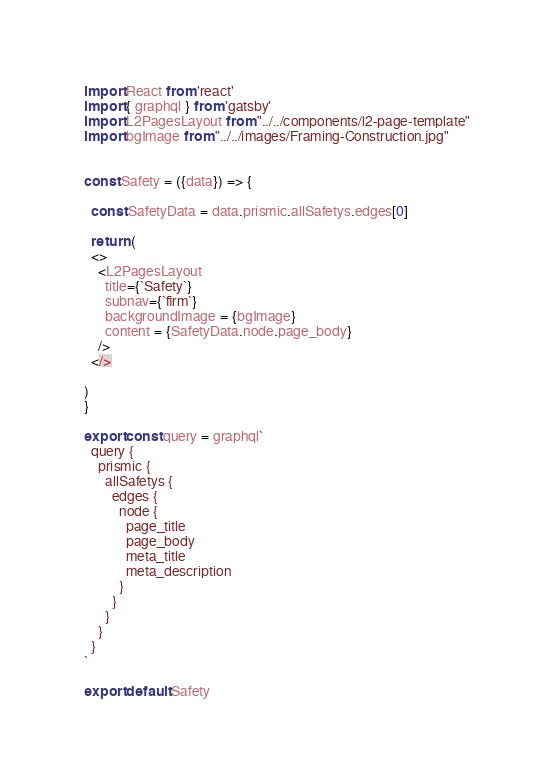Convert code to text. <code><loc_0><loc_0><loc_500><loc_500><_JavaScript_>import React from 'react'
import { graphql } from 'gatsby'
import L2PagesLayout from "../../components/l2-page-template"
import bgImage from "../../images/Framing-Construction.jpg"


const Safety = ({data}) => {
  
  const SafetyData = data.prismic.allSafetys.edges[0]
  
  return (
  <>
    <L2PagesLayout 
      title={`Safety`}
      subnav={`firm`}
      backgroundImage = {bgImage}
      content = {SafetyData.node.page_body}
    />
  </>
  
)
}

export const query = graphql`
  query {
    prismic {
      allSafetys {
        edges {
          node {
            page_title
            page_body
            meta_title
            meta_description
          }
        }
      }
    }
  }
`

export default Safety

</code> 